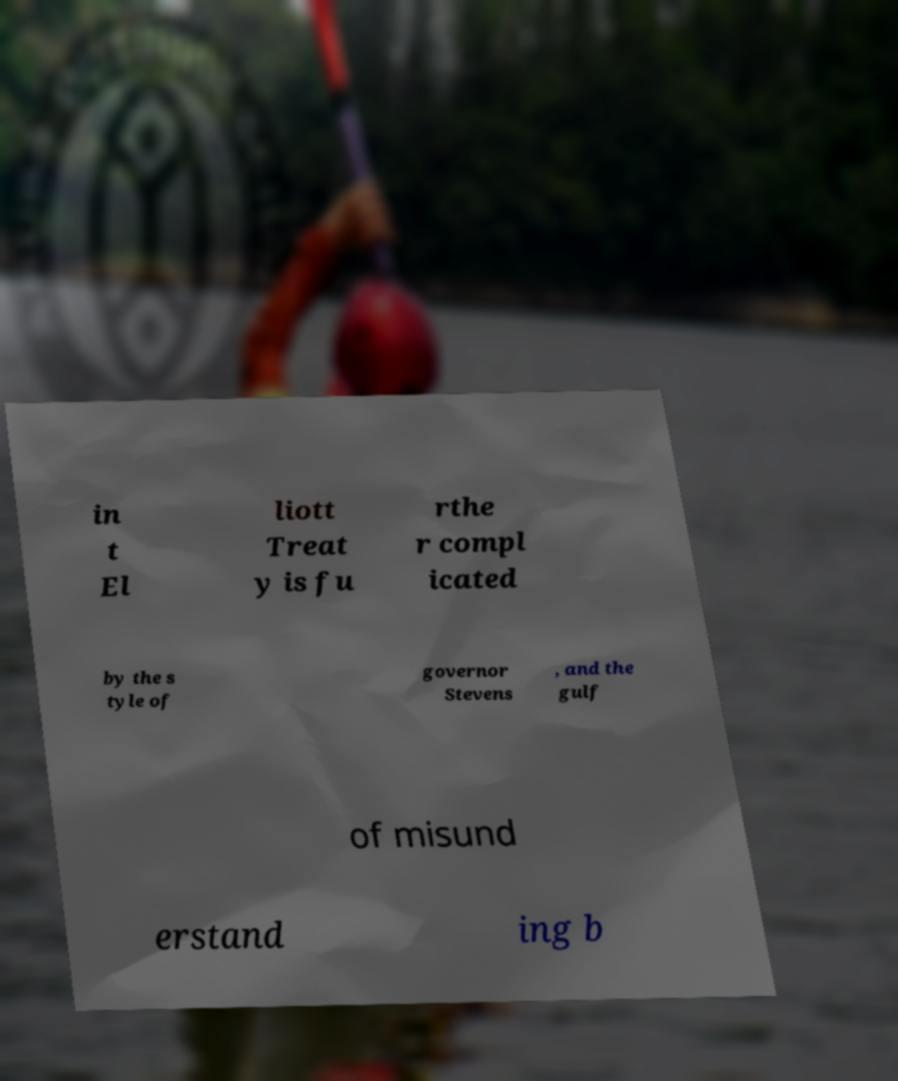Please read and relay the text visible in this image. What does it say? in t El liott Treat y is fu rthe r compl icated by the s tyle of governor Stevens , and the gulf of misund erstand ing b 